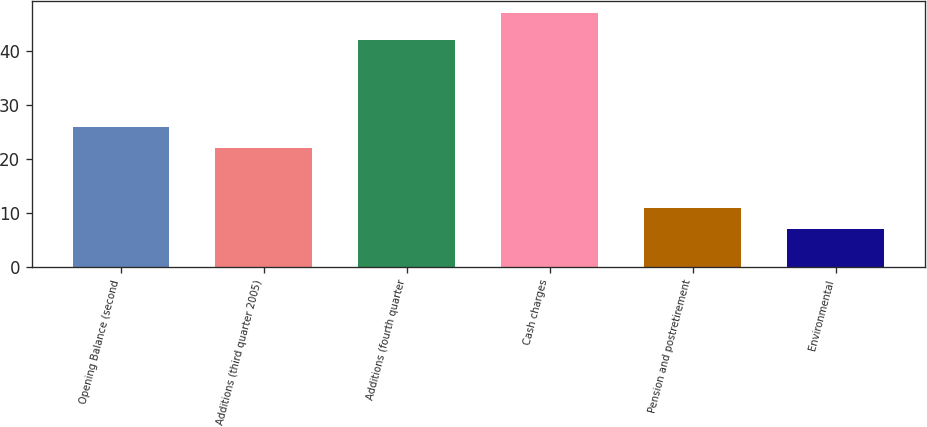Convert chart. <chart><loc_0><loc_0><loc_500><loc_500><bar_chart><fcel>Opening Balance (second<fcel>Additions (third quarter 2005)<fcel>Additions (fourth quarter<fcel>Cash charges<fcel>Pension and postretirement<fcel>Environmental<nl><fcel>26<fcel>22<fcel>42<fcel>47<fcel>11<fcel>7<nl></chart> 